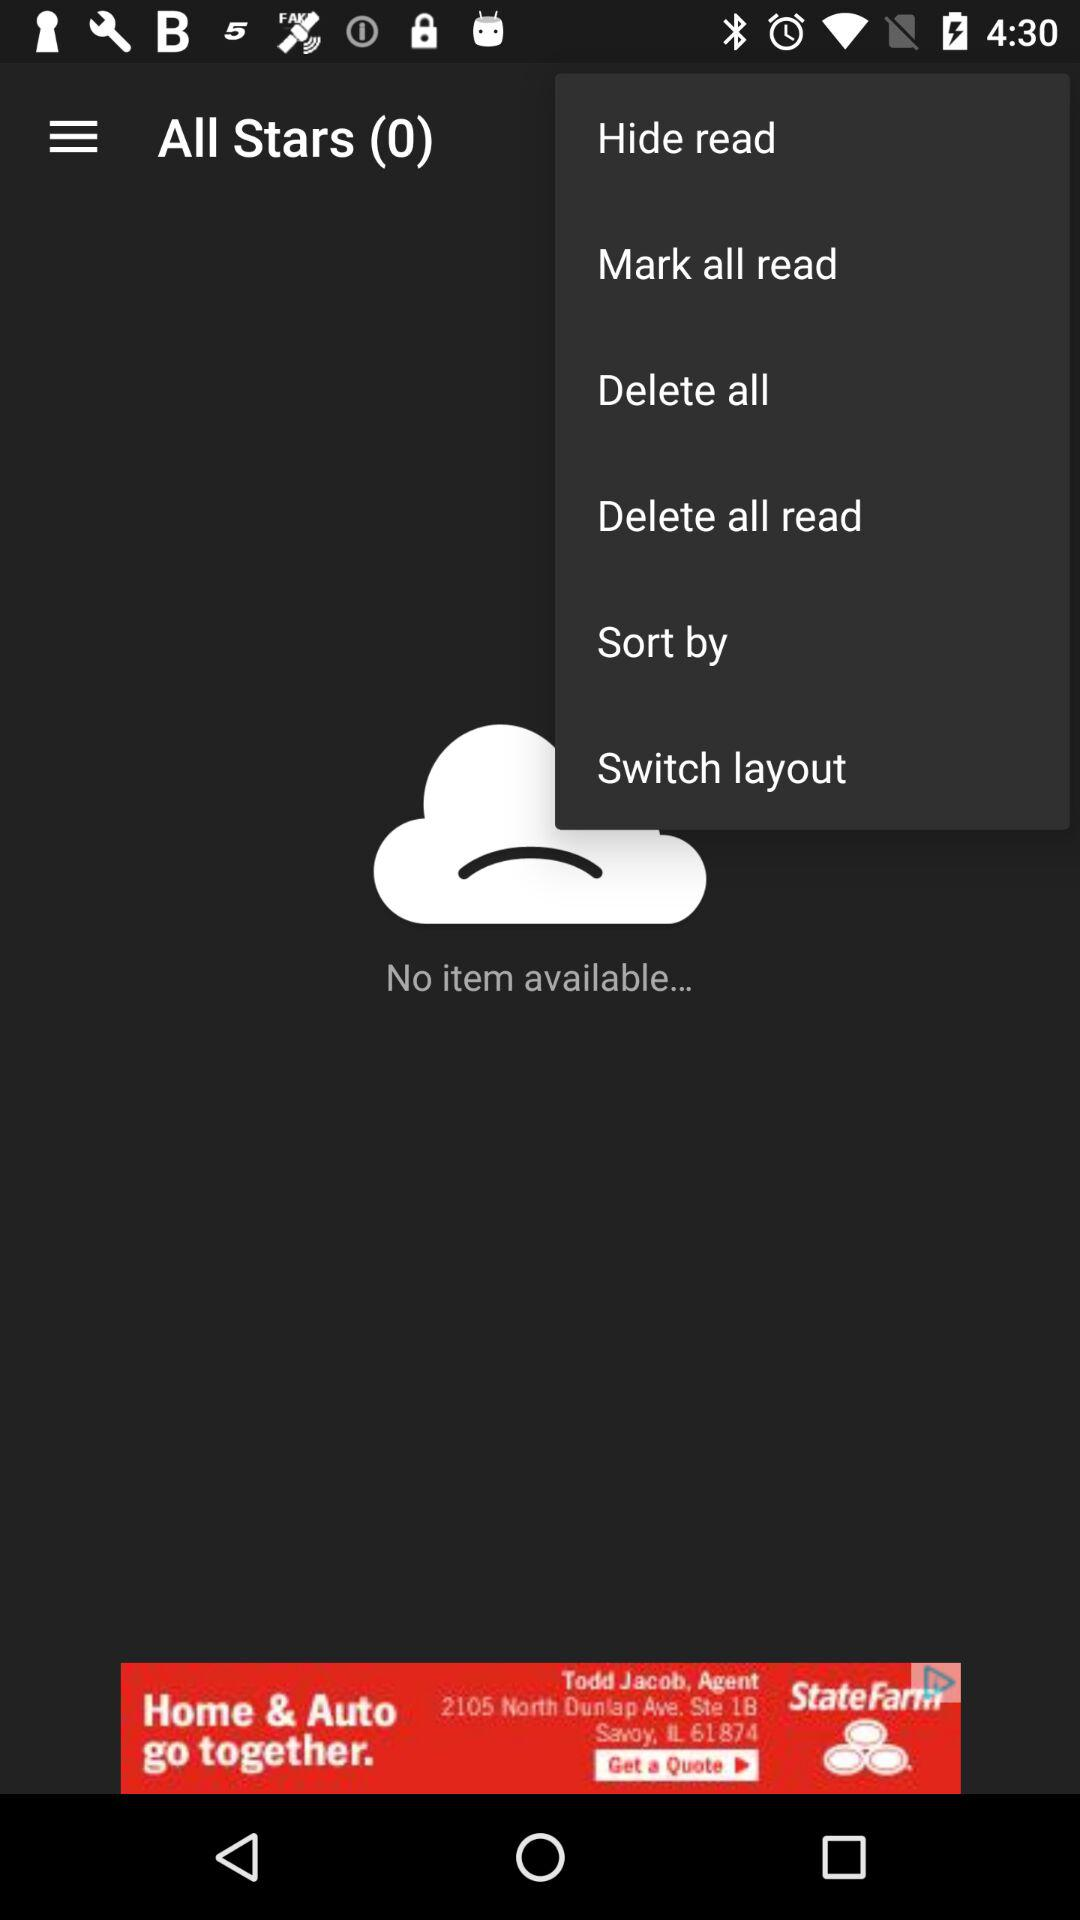Which option is selected in the drop-down menu?
When the provided information is insufficient, respond with <no answer>. <no answer> 